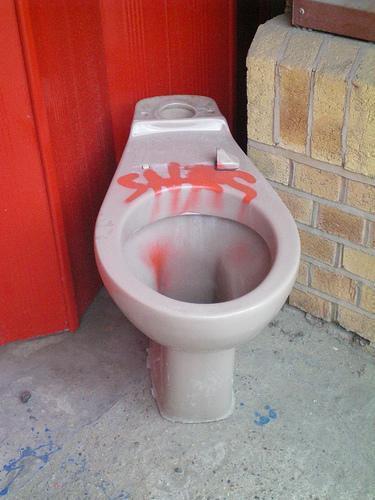How many boats are in this photo?
Give a very brief answer. 0. 